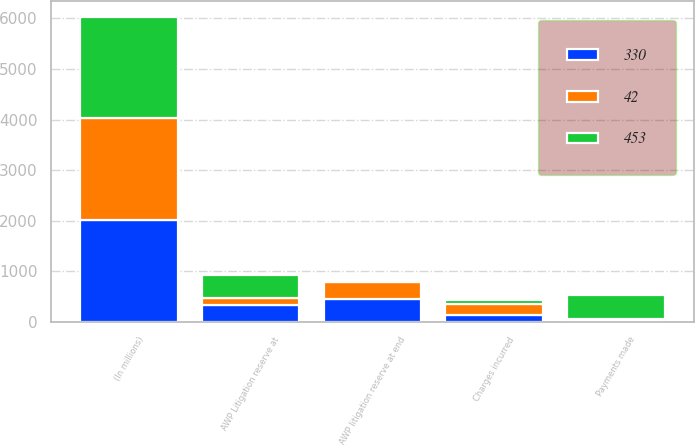<chart> <loc_0><loc_0><loc_500><loc_500><stacked_bar_chart><ecel><fcel>(In millions)<fcel>AWP Litigation reserve at<fcel>Charges incurred<fcel>Payments made<fcel>AWP litigation reserve at end<nl><fcel>453<fcel>2013<fcel>453<fcel>72<fcel>483<fcel>42<nl><fcel>330<fcel>2012<fcel>330<fcel>149<fcel>26<fcel>453<nl><fcel>42<fcel>2011<fcel>143<fcel>213<fcel>26<fcel>330<nl></chart> 